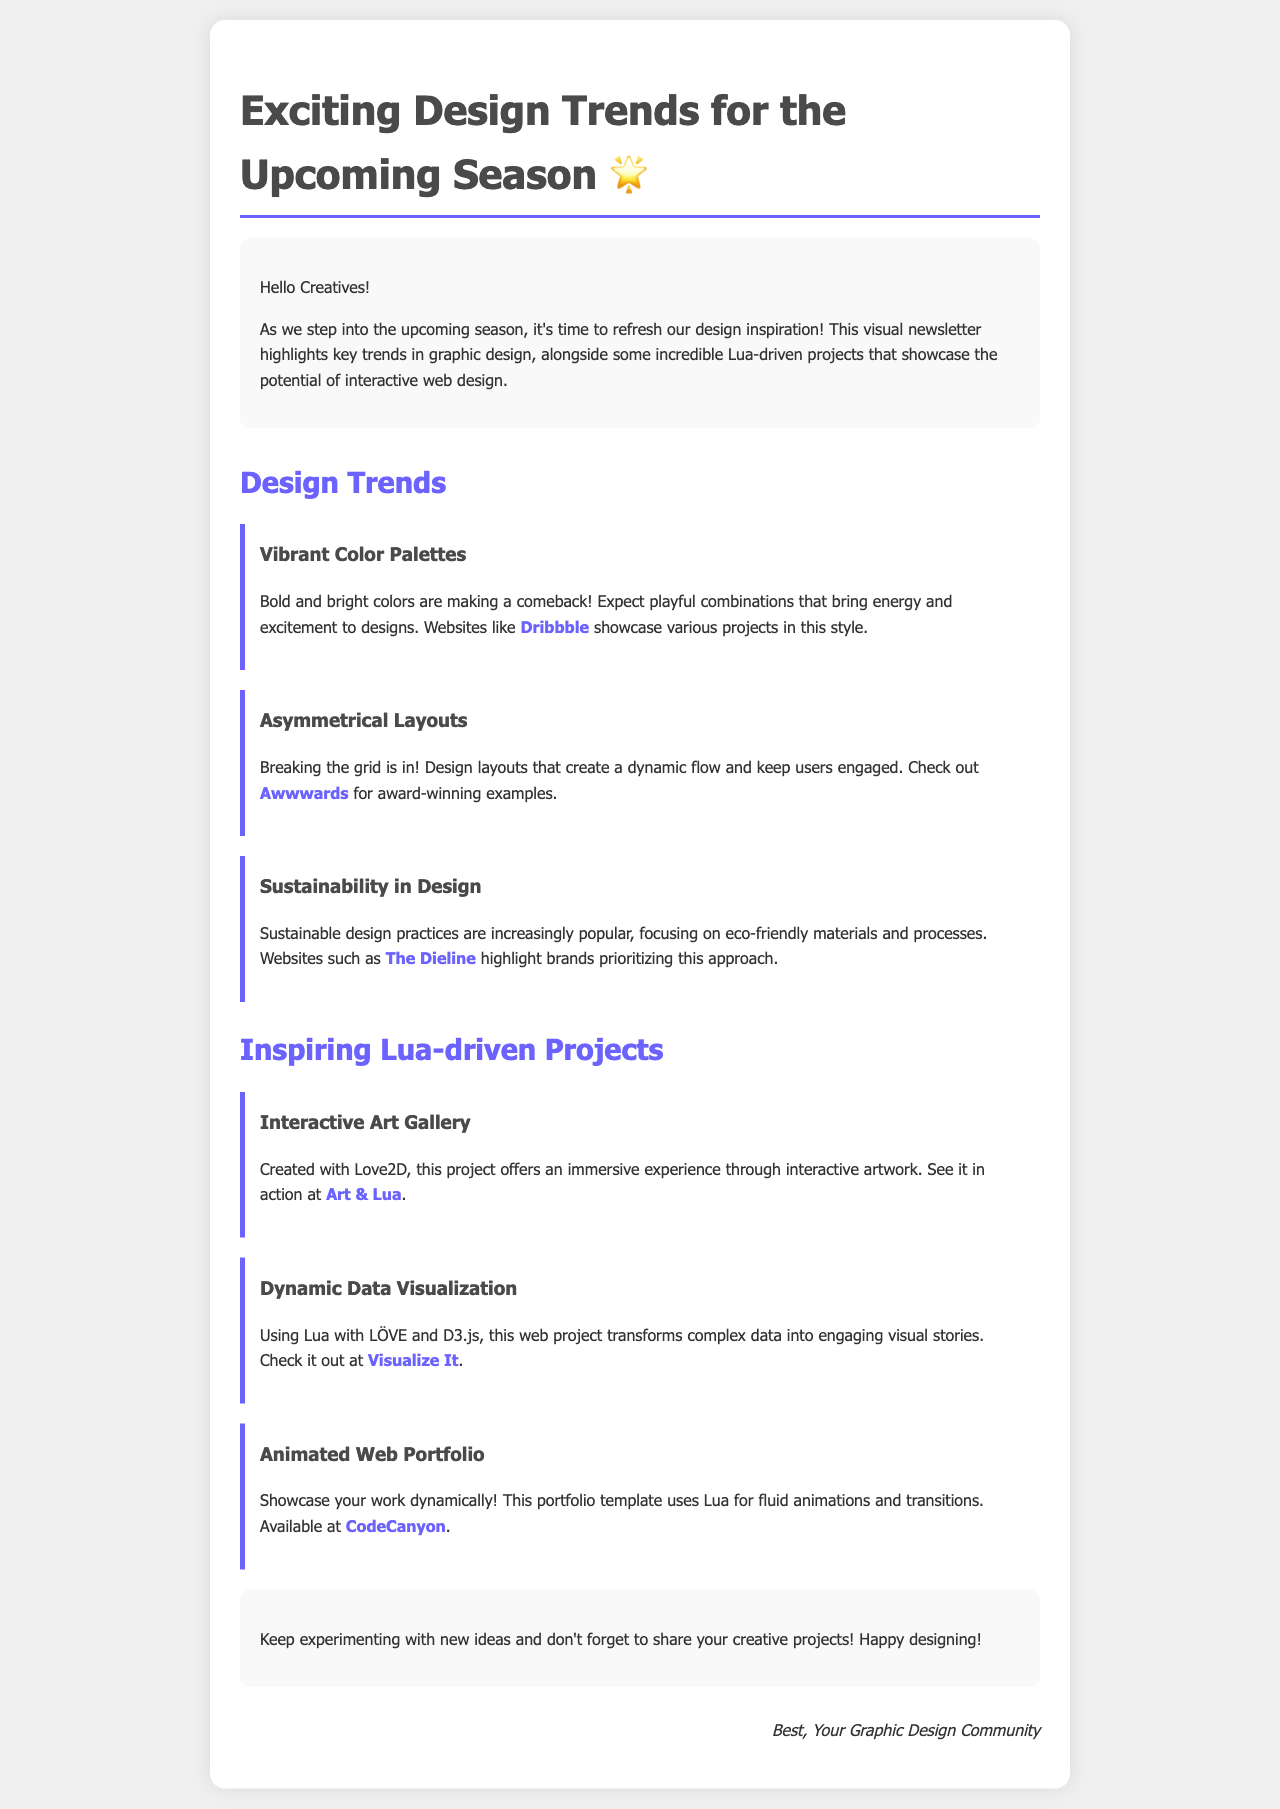What is the title of the newsletter? The title is provided in the header of the document.
Answer: Exciting Design Trends for the Upcoming Season 🌟 Who is the intended audience for this newsletter? The introduction addresses the audience directly.
Answer: Creatives Which website is mentioned for vibrant color palettes? The document specifies a website as an example for this trend.
Answer: Dribbble What design trend breaks the grid? The document explicitly states a trend that involves breaking traditional layouts.
Answer: Asymmetrical Layouts How many Lua-driven projects are listed in the newsletter? The document lists the projects under a specific section.
Answer: Three What color is used for the trend headings? The color used in the trend headings is mentioned in the document details.
Answer: #4a4a4a Which project uses Love2D for an interactive experience? This project is mentioned under Lua-driven projects due to its unique features.
Answer: Interactive Art Gallery What is the main focus of sustainable design practices? The document summarizes key aspects of sustainable design.
Answer: Eco-friendly materials 